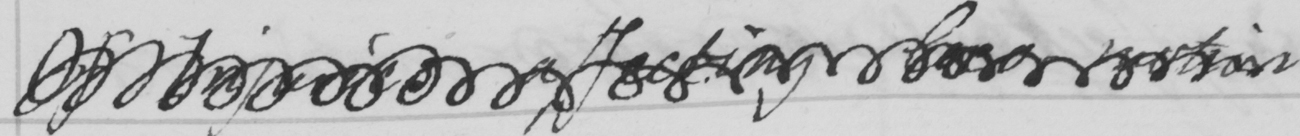What text is written in this handwritten line? Of Injuries affecting loco-motion 